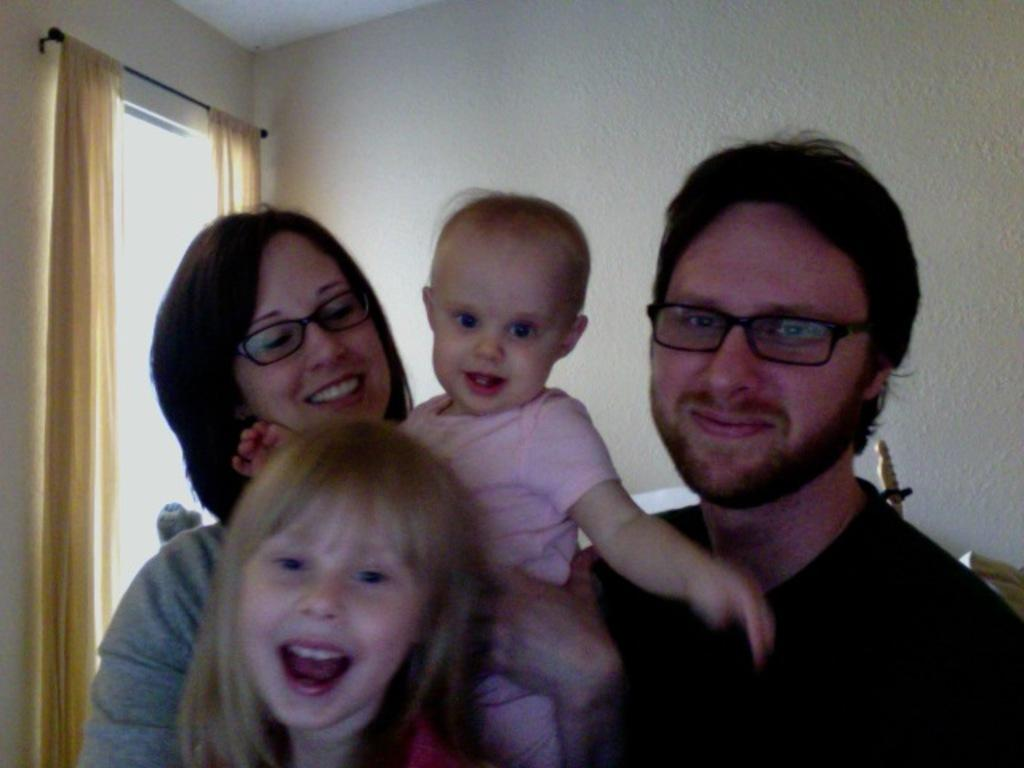How many people are in the room? There are people in the room, but the exact number is not specified. What is the person holding in the image? The person is holding a baby. What can be seen in the background of the image? There is a wall in the background. What is the window treatment in the image? There is a window with curtains on the left side. What type of dress is the person wearing in the image? There is no mention of a dress in the image, as the person is holding a baby. 